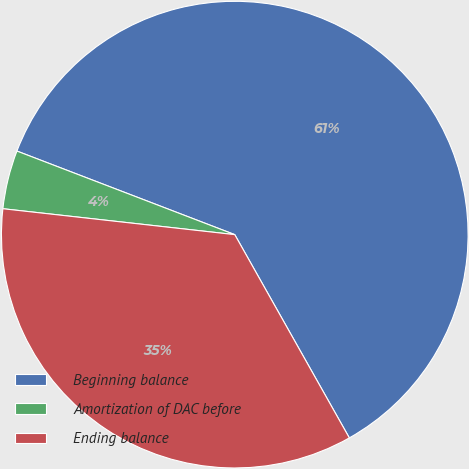<chart> <loc_0><loc_0><loc_500><loc_500><pie_chart><fcel>Beginning balance<fcel>Amortization of DAC before<fcel>Ending balance<nl><fcel>61.0%<fcel>4.06%<fcel>34.94%<nl></chart> 